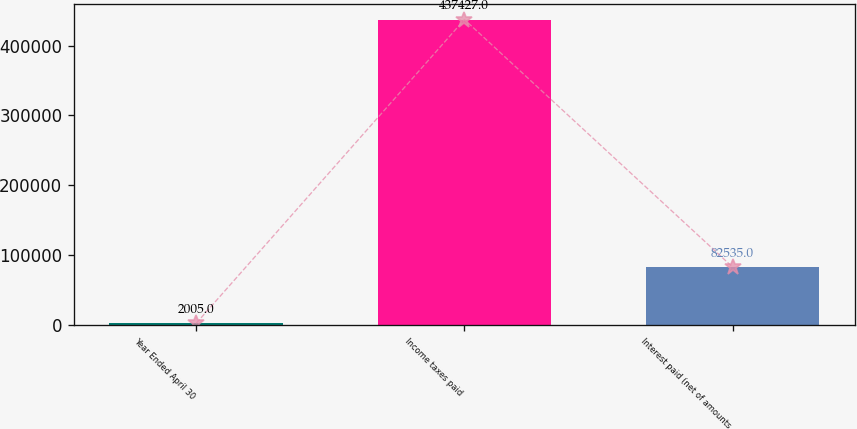<chart> <loc_0><loc_0><loc_500><loc_500><bar_chart><fcel>Year Ended April 30<fcel>Income taxes paid<fcel>Interest paid (net of amounts<nl><fcel>2005<fcel>437427<fcel>82535<nl></chart> 